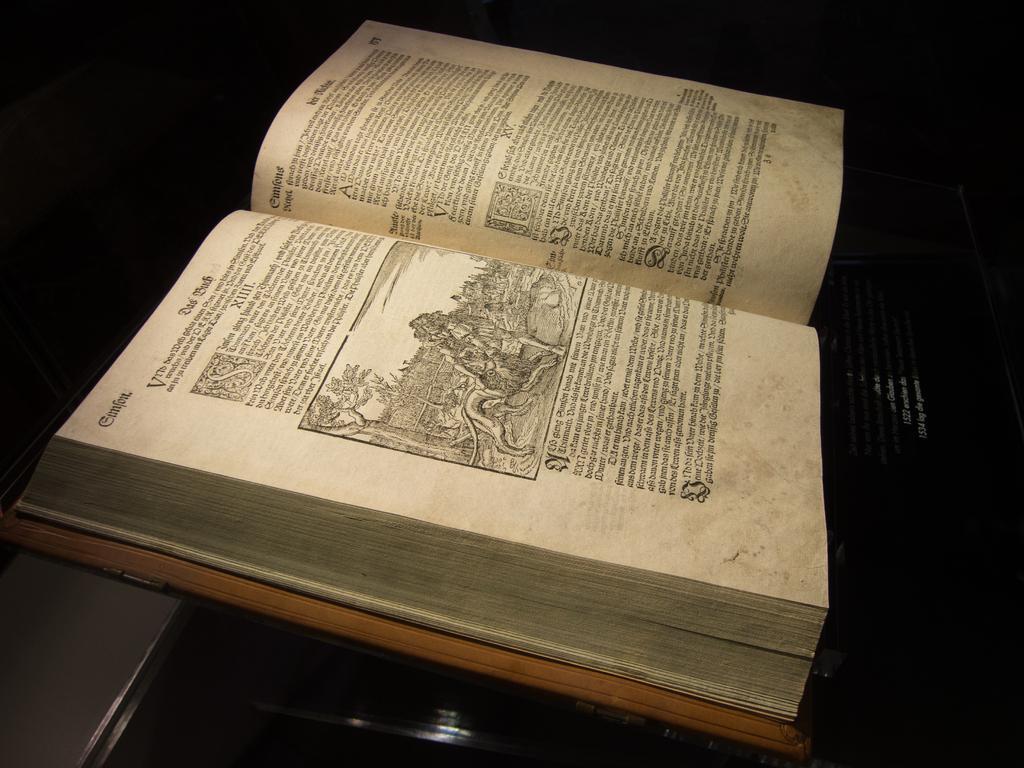Describe this image in one or two sentences. In the picture we can see a desk on it we can see a book which is opened and in it we can see information and some image on it. 